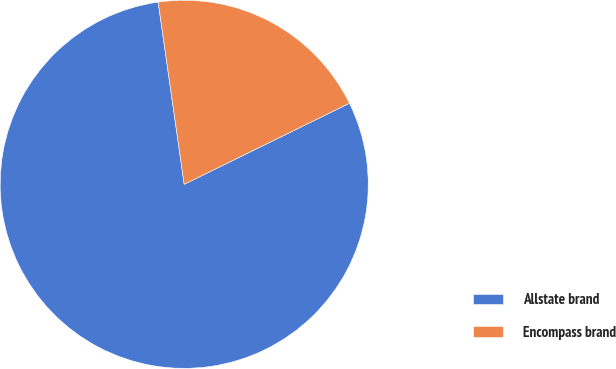<chart> <loc_0><loc_0><loc_500><loc_500><pie_chart><fcel>Allstate brand<fcel>Encompass brand<nl><fcel>80.0%<fcel>20.0%<nl></chart> 